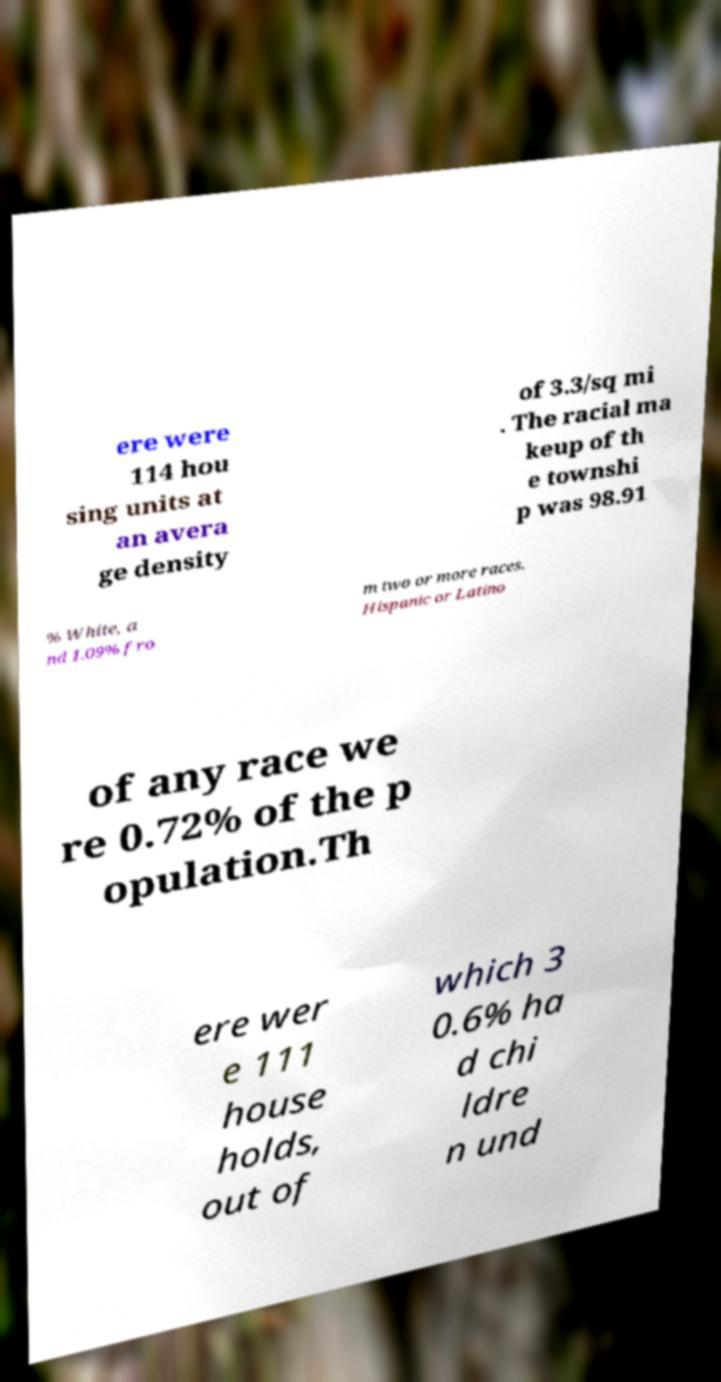Could you assist in decoding the text presented in this image and type it out clearly? ere were 114 hou sing units at an avera ge density of 3.3/sq mi . The racial ma keup of th e townshi p was 98.91 % White, a nd 1.09% fro m two or more races. Hispanic or Latino of any race we re 0.72% of the p opulation.Th ere wer e 111 house holds, out of which 3 0.6% ha d chi ldre n und 